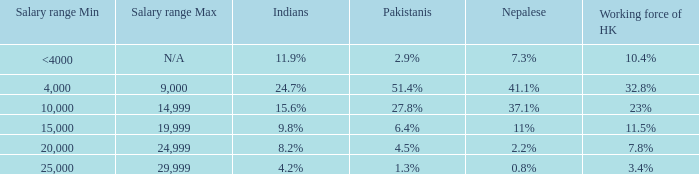If the salary range is 4,000-9,000, what is the Indians %? 24.7%. 